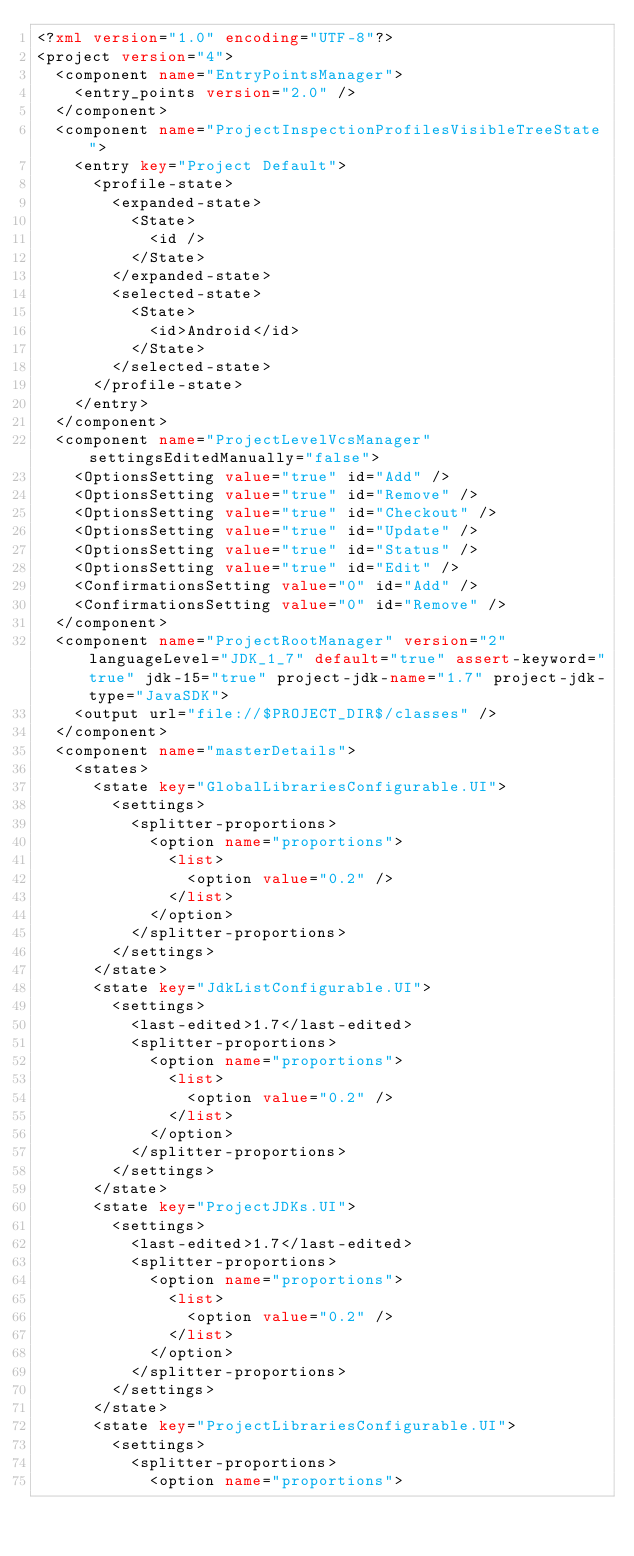<code> <loc_0><loc_0><loc_500><loc_500><_XML_><?xml version="1.0" encoding="UTF-8"?>
<project version="4">
  <component name="EntryPointsManager">
    <entry_points version="2.0" />
  </component>
  <component name="ProjectInspectionProfilesVisibleTreeState">
    <entry key="Project Default">
      <profile-state>
        <expanded-state>
          <State>
            <id />
          </State>
        </expanded-state>
        <selected-state>
          <State>
            <id>Android</id>
          </State>
        </selected-state>
      </profile-state>
    </entry>
  </component>
  <component name="ProjectLevelVcsManager" settingsEditedManually="false">
    <OptionsSetting value="true" id="Add" />
    <OptionsSetting value="true" id="Remove" />
    <OptionsSetting value="true" id="Checkout" />
    <OptionsSetting value="true" id="Update" />
    <OptionsSetting value="true" id="Status" />
    <OptionsSetting value="true" id="Edit" />
    <ConfirmationsSetting value="0" id="Add" />
    <ConfirmationsSetting value="0" id="Remove" />
  </component>
  <component name="ProjectRootManager" version="2" languageLevel="JDK_1_7" default="true" assert-keyword="true" jdk-15="true" project-jdk-name="1.7" project-jdk-type="JavaSDK">
    <output url="file://$PROJECT_DIR$/classes" />
  </component>
  <component name="masterDetails">
    <states>
      <state key="GlobalLibrariesConfigurable.UI">
        <settings>
          <splitter-proportions>
            <option name="proportions">
              <list>
                <option value="0.2" />
              </list>
            </option>
          </splitter-proportions>
        </settings>
      </state>
      <state key="JdkListConfigurable.UI">
        <settings>
          <last-edited>1.7</last-edited>
          <splitter-proportions>
            <option name="proportions">
              <list>
                <option value="0.2" />
              </list>
            </option>
          </splitter-proportions>
        </settings>
      </state>
      <state key="ProjectJDKs.UI">
        <settings>
          <last-edited>1.7</last-edited>
          <splitter-proportions>
            <option name="proportions">
              <list>
                <option value="0.2" />
              </list>
            </option>
          </splitter-proportions>
        </settings>
      </state>
      <state key="ProjectLibrariesConfigurable.UI">
        <settings>
          <splitter-proportions>
            <option name="proportions"></code> 